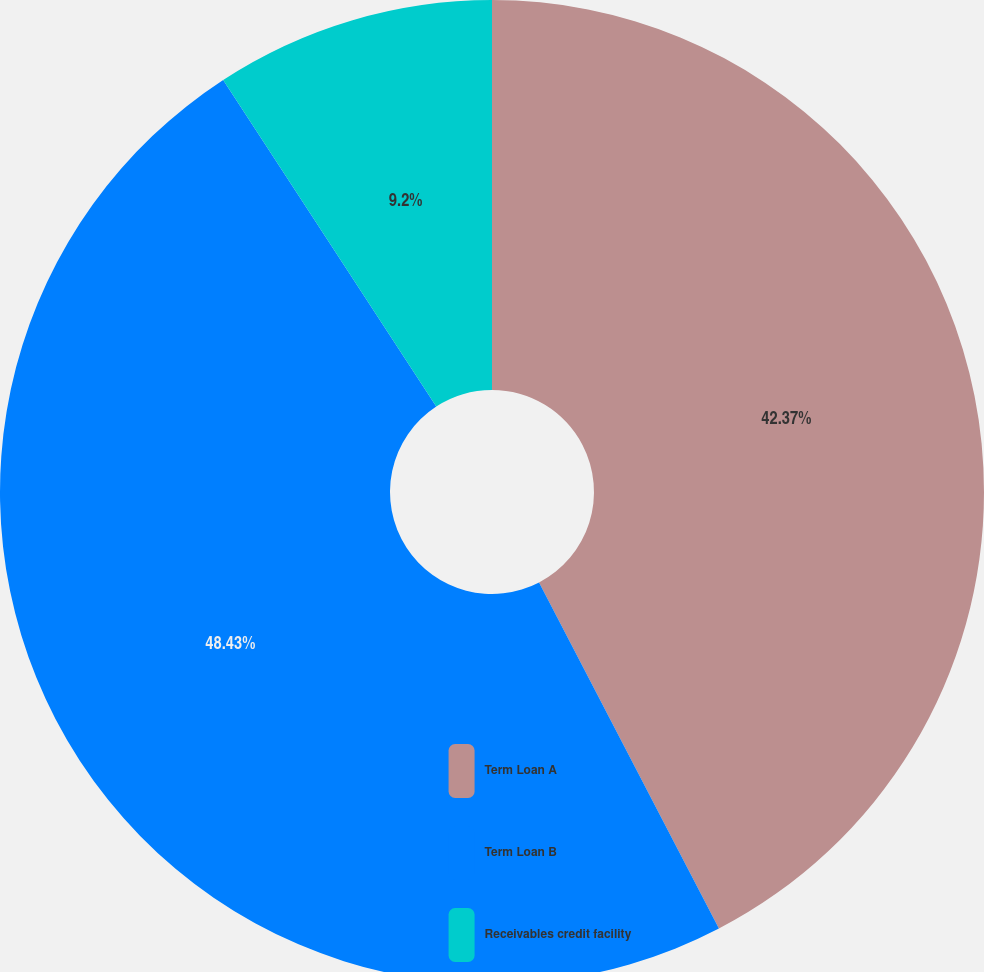Convert chart to OTSL. <chart><loc_0><loc_0><loc_500><loc_500><pie_chart><fcel>Term Loan A<fcel>Term Loan B<fcel>Receivables credit facility<nl><fcel>42.37%<fcel>48.43%<fcel>9.2%<nl></chart> 